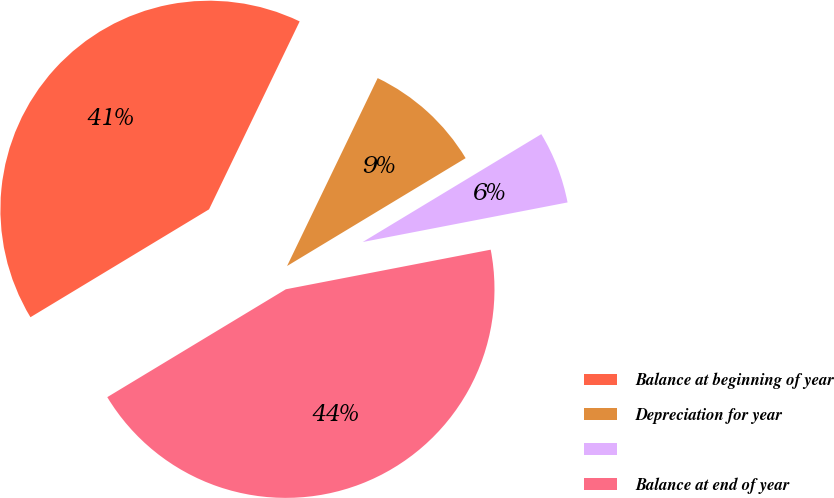Convert chart. <chart><loc_0><loc_0><loc_500><loc_500><pie_chart><fcel>Balance at beginning of year<fcel>Depreciation for year<fcel>Unnamed: 2<fcel>Balance at end of year<nl><fcel>40.8%<fcel>9.2%<fcel>5.61%<fcel>44.39%<nl></chart> 